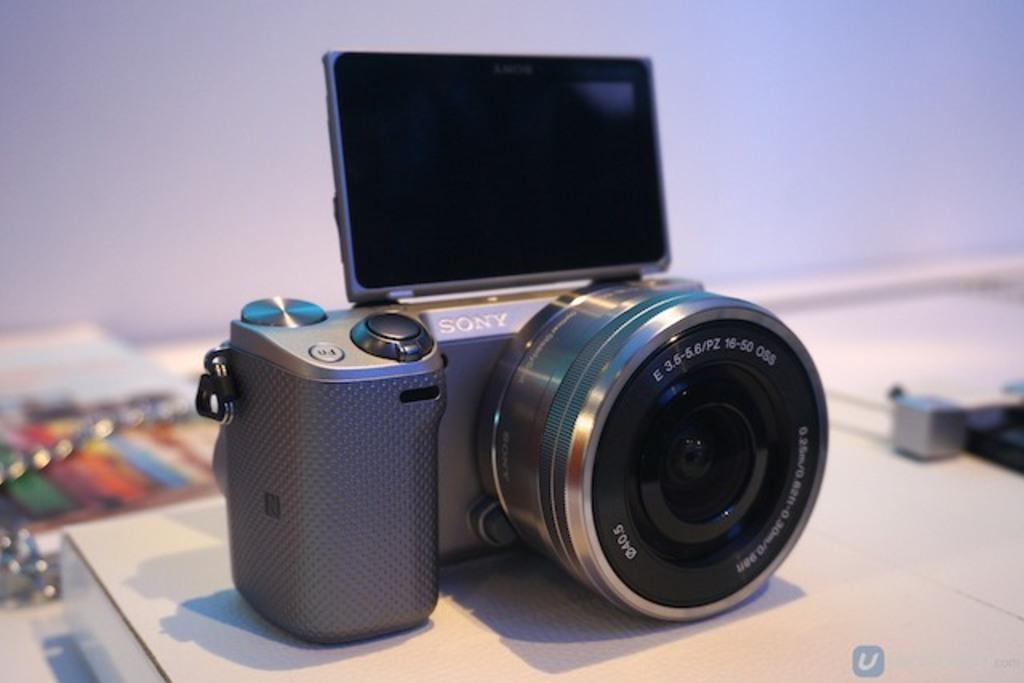What object is the main subject of the image? There is a camera in the image. Where is the camera located? The camera is placed on a table. What can be seen in the background of the image? There is a wall visible in the background of the image. How many cherries are hanging from the camera in the image? There are no cherries present in the image; the main subject is a camera placed on a table. 